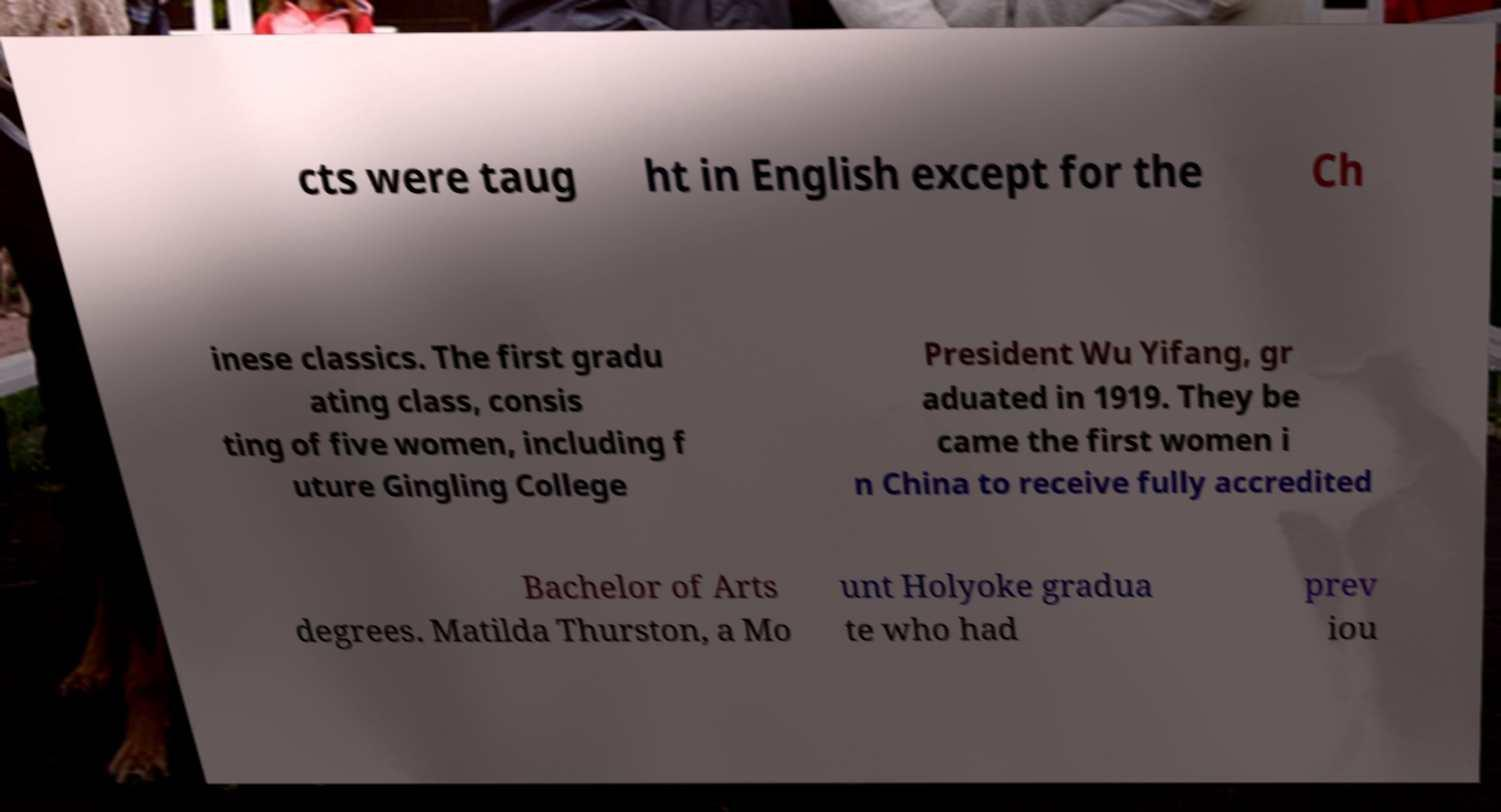Can you accurately transcribe the text from the provided image for me? cts were taug ht in English except for the Ch inese classics. The first gradu ating class, consis ting of five women, including f uture Gingling College President Wu Yifang, gr aduated in 1919. They be came the first women i n China to receive fully accredited Bachelor of Arts degrees. Matilda Thurston, a Mo unt Holyoke gradua te who had prev iou 